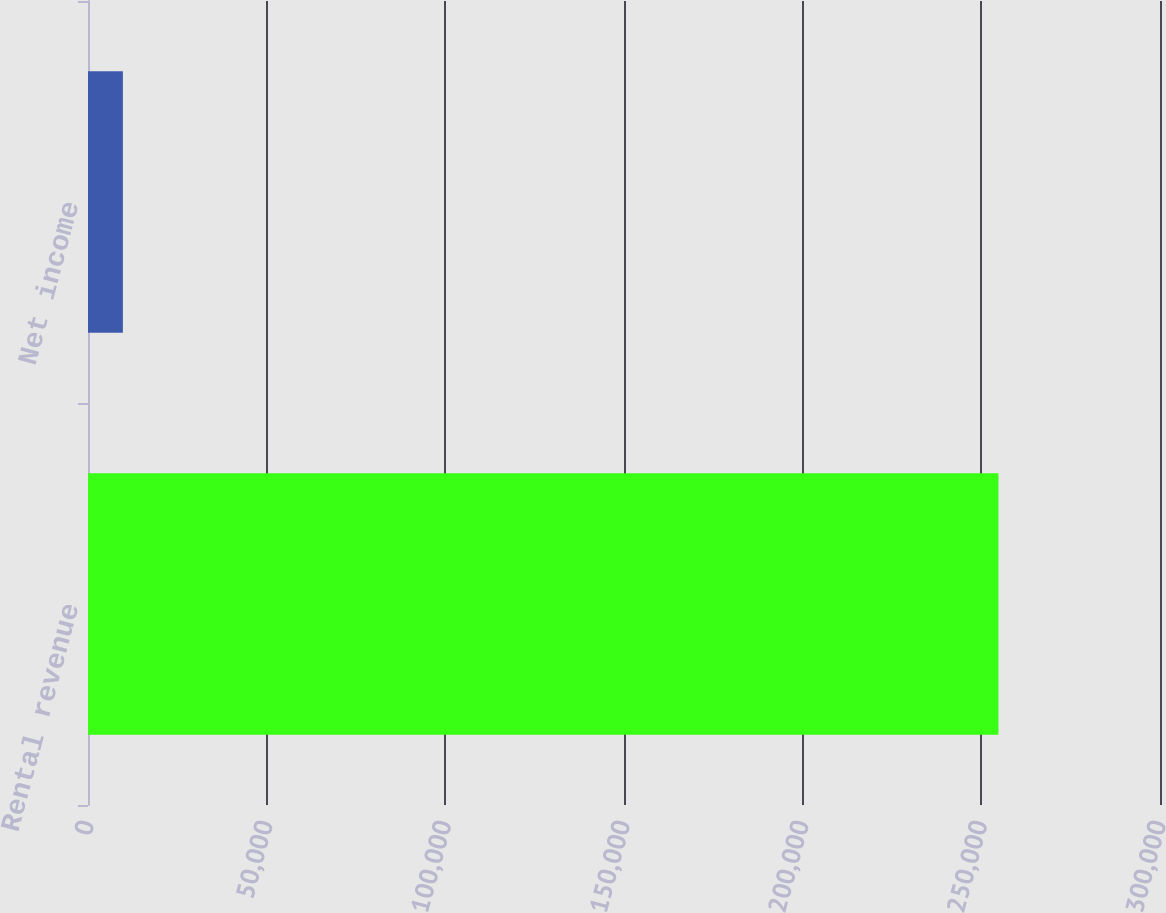<chart> <loc_0><loc_0><loc_500><loc_500><bar_chart><fcel>Rental revenue<fcel>Net income<nl><fcel>254787<fcel>9760<nl></chart> 